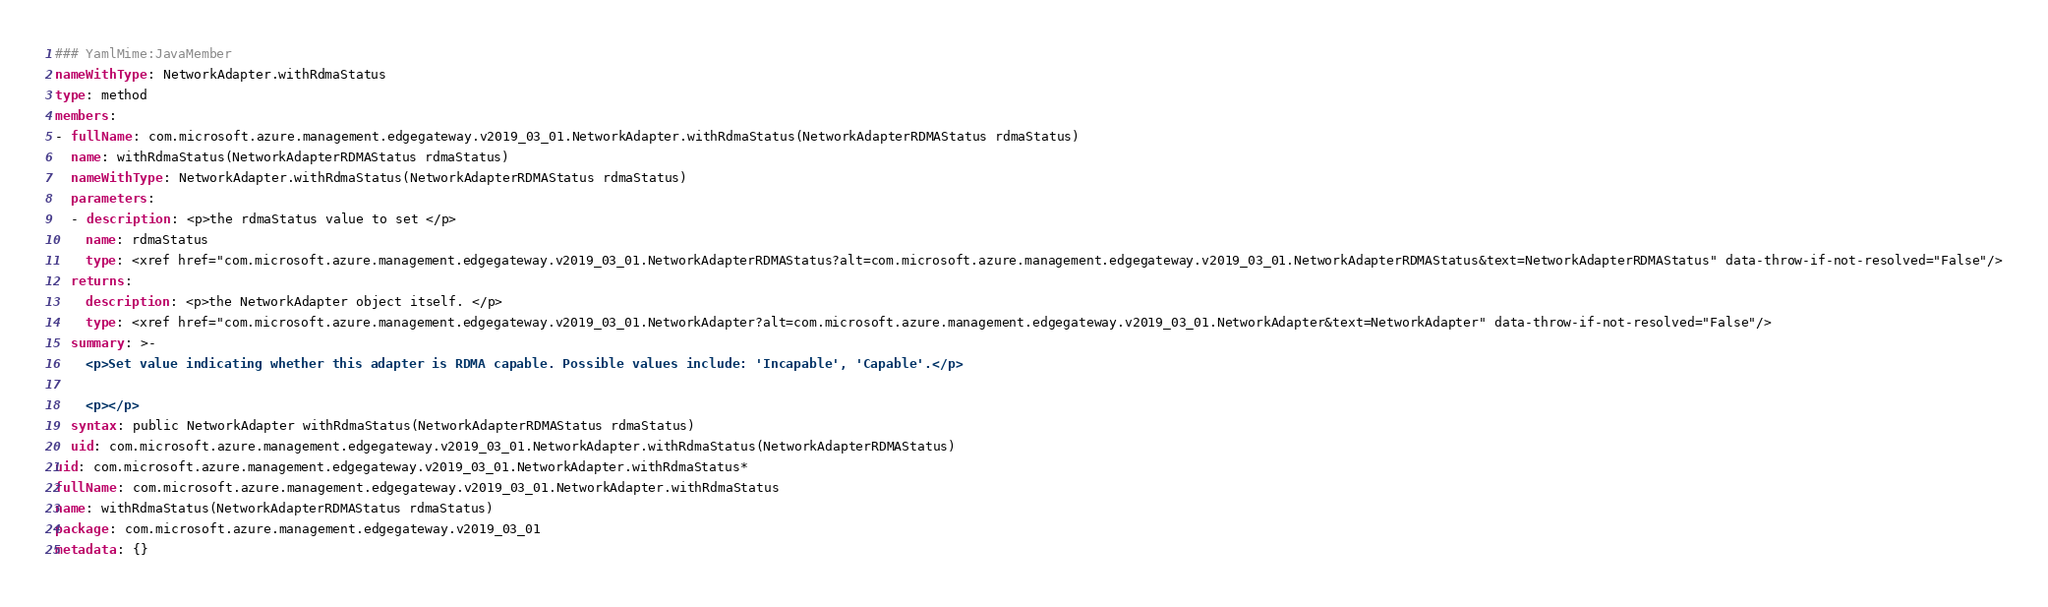<code> <loc_0><loc_0><loc_500><loc_500><_YAML_>### YamlMime:JavaMember
nameWithType: NetworkAdapter.withRdmaStatus
type: method
members:
- fullName: com.microsoft.azure.management.edgegateway.v2019_03_01.NetworkAdapter.withRdmaStatus(NetworkAdapterRDMAStatus rdmaStatus)
  name: withRdmaStatus(NetworkAdapterRDMAStatus rdmaStatus)
  nameWithType: NetworkAdapter.withRdmaStatus(NetworkAdapterRDMAStatus rdmaStatus)
  parameters:
  - description: <p>the rdmaStatus value to set </p>
    name: rdmaStatus
    type: <xref href="com.microsoft.azure.management.edgegateway.v2019_03_01.NetworkAdapterRDMAStatus?alt=com.microsoft.azure.management.edgegateway.v2019_03_01.NetworkAdapterRDMAStatus&text=NetworkAdapterRDMAStatus" data-throw-if-not-resolved="False"/>
  returns:
    description: <p>the NetworkAdapter object itself. </p>
    type: <xref href="com.microsoft.azure.management.edgegateway.v2019_03_01.NetworkAdapter?alt=com.microsoft.azure.management.edgegateway.v2019_03_01.NetworkAdapter&text=NetworkAdapter" data-throw-if-not-resolved="False"/>
  summary: >-
    <p>Set value indicating whether this adapter is RDMA capable. Possible values include: 'Incapable', 'Capable'.</p>

    <p></p>
  syntax: public NetworkAdapter withRdmaStatus(NetworkAdapterRDMAStatus rdmaStatus)
  uid: com.microsoft.azure.management.edgegateway.v2019_03_01.NetworkAdapter.withRdmaStatus(NetworkAdapterRDMAStatus)
uid: com.microsoft.azure.management.edgegateway.v2019_03_01.NetworkAdapter.withRdmaStatus*
fullName: com.microsoft.azure.management.edgegateway.v2019_03_01.NetworkAdapter.withRdmaStatus
name: withRdmaStatus(NetworkAdapterRDMAStatus rdmaStatus)
package: com.microsoft.azure.management.edgegateway.v2019_03_01
metadata: {}
</code> 